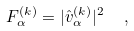<formula> <loc_0><loc_0><loc_500><loc_500>F ^ { ( k ) } _ { \alpha } = | \hat { v } ^ { ( k ) } _ { \alpha } | ^ { 2 } \ \ ,</formula> 